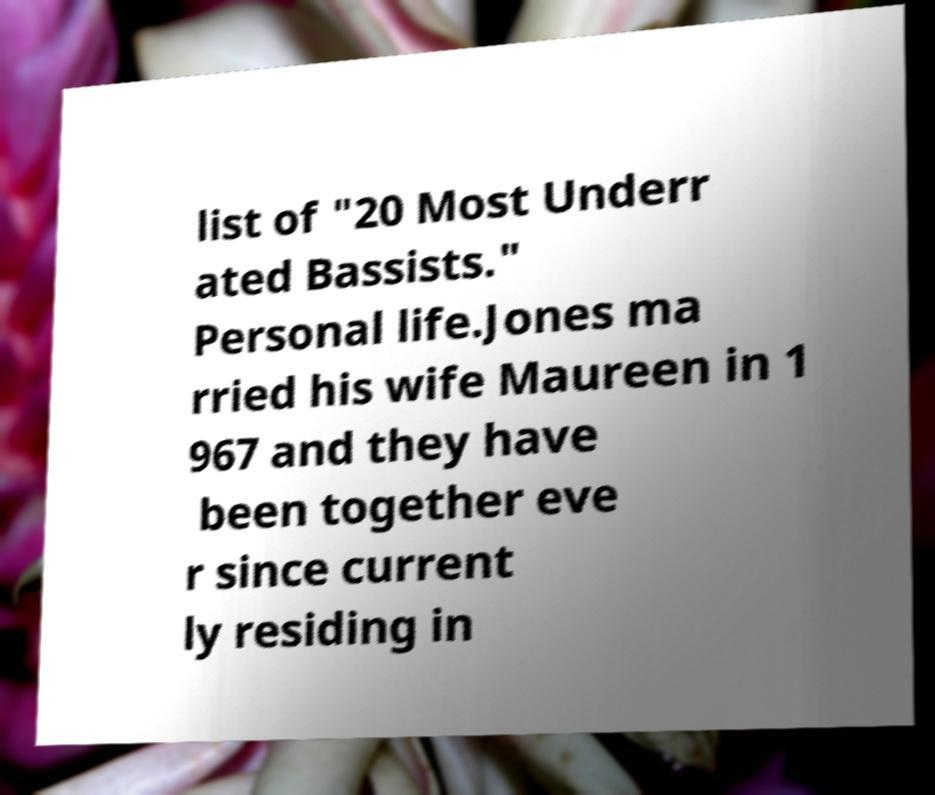I need the written content from this picture converted into text. Can you do that? list of "20 Most Underr ated Bassists." Personal life.Jones ma rried his wife Maureen in 1 967 and they have been together eve r since current ly residing in 